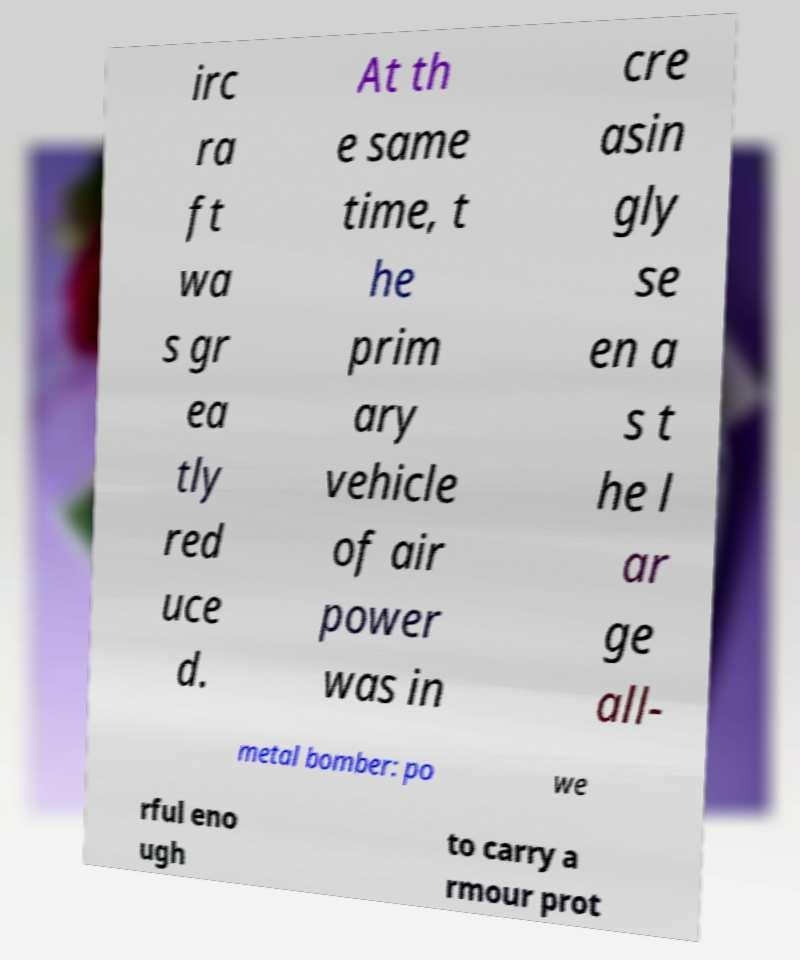Could you extract and type out the text from this image? irc ra ft wa s gr ea tly red uce d. At th e same time, t he prim ary vehicle of air power was in cre asin gly se en a s t he l ar ge all- metal bomber: po we rful eno ugh to carry a rmour prot 